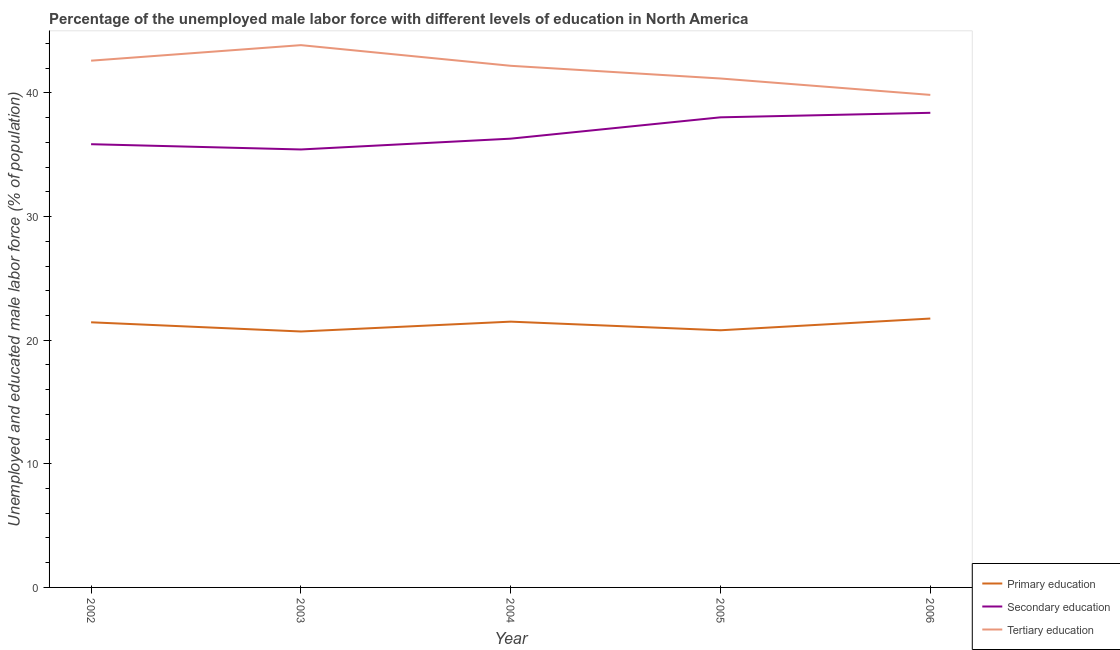How many different coloured lines are there?
Your answer should be very brief. 3. What is the percentage of male labor force who received tertiary education in 2005?
Your answer should be very brief. 41.17. Across all years, what is the maximum percentage of male labor force who received secondary education?
Provide a succinct answer. 38.39. Across all years, what is the minimum percentage of male labor force who received tertiary education?
Provide a short and direct response. 39.84. In which year was the percentage of male labor force who received primary education maximum?
Your answer should be compact. 2006. What is the total percentage of male labor force who received secondary education in the graph?
Offer a terse response. 184.01. What is the difference between the percentage of male labor force who received secondary education in 2005 and that in 2006?
Your answer should be compact. -0.36. What is the difference between the percentage of male labor force who received primary education in 2003 and the percentage of male labor force who received tertiary education in 2002?
Give a very brief answer. -21.91. What is the average percentage of male labor force who received tertiary education per year?
Offer a very short reply. 41.94. In the year 2003, what is the difference between the percentage of male labor force who received primary education and percentage of male labor force who received tertiary education?
Provide a short and direct response. -23.16. In how many years, is the percentage of male labor force who received secondary education greater than 2 %?
Provide a succinct answer. 5. What is the ratio of the percentage of male labor force who received secondary education in 2002 to that in 2004?
Provide a succinct answer. 0.99. Is the percentage of male labor force who received secondary education in 2002 less than that in 2005?
Offer a terse response. Yes. Is the difference between the percentage of male labor force who received primary education in 2002 and 2005 greater than the difference between the percentage of male labor force who received tertiary education in 2002 and 2005?
Provide a succinct answer. No. What is the difference between the highest and the second highest percentage of male labor force who received primary education?
Offer a very short reply. 0.25. What is the difference between the highest and the lowest percentage of male labor force who received tertiary education?
Provide a succinct answer. 4.02. In how many years, is the percentage of male labor force who received tertiary education greater than the average percentage of male labor force who received tertiary education taken over all years?
Your response must be concise. 3. Does the percentage of male labor force who received tertiary education monotonically increase over the years?
Your answer should be compact. No. Is the percentage of male labor force who received primary education strictly less than the percentage of male labor force who received tertiary education over the years?
Provide a short and direct response. Yes. Are the values on the major ticks of Y-axis written in scientific E-notation?
Provide a succinct answer. No. Does the graph contain any zero values?
Your answer should be very brief. No. How many legend labels are there?
Your response must be concise. 3. What is the title of the graph?
Offer a very short reply. Percentage of the unemployed male labor force with different levels of education in North America. What is the label or title of the Y-axis?
Keep it short and to the point. Unemployed and educated male labor force (% of population). What is the Unemployed and educated male labor force (% of population) of Primary education in 2002?
Provide a succinct answer. 21.45. What is the Unemployed and educated male labor force (% of population) in Secondary education in 2002?
Offer a terse response. 35.85. What is the Unemployed and educated male labor force (% of population) in Tertiary education in 2002?
Provide a short and direct response. 42.61. What is the Unemployed and educated male labor force (% of population) of Primary education in 2003?
Your answer should be compact. 20.7. What is the Unemployed and educated male labor force (% of population) in Secondary education in 2003?
Ensure brevity in your answer.  35.43. What is the Unemployed and educated male labor force (% of population) of Tertiary education in 2003?
Offer a very short reply. 43.87. What is the Unemployed and educated male labor force (% of population) of Primary education in 2004?
Make the answer very short. 21.5. What is the Unemployed and educated male labor force (% of population) of Secondary education in 2004?
Offer a very short reply. 36.3. What is the Unemployed and educated male labor force (% of population) of Tertiary education in 2004?
Keep it short and to the point. 42.2. What is the Unemployed and educated male labor force (% of population) of Primary education in 2005?
Provide a short and direct response. 20.8. What is the Unemployed and educated male labor force (% of population) in Secondary education in 2005?
Keep it short and to the point. 38.03. What is the Unemployed and educated male labor force (% of population) of Tertiary education in 2005?
Offer a very short reply. 41.17. What is the Unemployed and educated male labor force (% of population) in Primary education in 2006?
Your answer should be very brief. 21.75. What is the Unemployed and educated male labor force (% of population) in Secondary education in 2006?
Offer a very short reply. 38.39. What is the Unemployed and educated male labor force (% of population) of Tertiary education in 2006?
Ensure brevity in your answer.  39.84. Across all years, what is the maximum Unemployed and educated male labor force (% of population) of Primary education?
Offer a very short reply. 21.75. Across all years, what is the maximum Unemployed and educated male labor force (% of population) of Secondary education?
Your answer should be very brief. 38.39. Across all years, what is the maximum Unemployed and educated male labor force (% of population) in Tertiary education?
Make the answer very short. 43.87. Across all years, what is the minimum Unemployed and educated male labor force (% of population) in Primary education?
Keep it short and to the point. 20.7. Across all years, what is the minimum Unemployed and educated male labor force (% of population) of Secondary education?
Make the answer very short. 35.43. Across all years, what is the minimum Unemployed and educated male labor force (% of population) of Tertiary education?
Your response must be concise. 39.84. What is the total Unemployed and educated male labor force (% of population) in Primary education in the graph?
Give a very brief answer. 106.21. What is the total Unemployed and educated male labor force (% of population) in Secondary education in the graph?
Give a very brief answer. 184.01. What is the total Unemployed and educated male labor force (% of population) of Tertiary education in the graph?
Ensure brevity in your answer.  209.69. What is the difference between the Unemployed and educated male labor force (% of population) in Primary education in 2002 and that in 2003?
Your answer should be compact. 0.74. What is the difference between the Unemployed and educated male labor force (% of population) in Secondary education in 2002 and that in 2003?
Your response must be concise. 0.43. What is the difference between the Unemployed and educated male labor force (% of population) of Tertiary education in 2002 and that in 2003?
Your response must be concise. -1.26. What is the difference between the Unemployed and educated male labor force (% of population) of Primary education in 2002 and that in 2004?
Your answer should be compact. -0.05. What is the difference between the Unemployed and educated male labor force (% of population) of Secondary education in 2002 and that in 2004?
Offer a very short reply. -0.45. What is the difference between the Unemployed and educated male labor force (% of population) in Tertiary education in 2002 and that in 2004?
Provide a short and direct response. 0.41. What is the difference between the Unemployed and educated male labor force (% of population) of Primary education in 2002 and that in 2005?
Your answer should be very brief. 0.65. What is the difference between the Unemployed and educated male labor force (% of population) of Secondary education in 2002 and that in 2005?
Make the answer very short. -2.17. What is the difference between the Unemployed and educated male labor force (% of population) of Tertiary education in 2002 and that in 2005?
Provide a short and direct response. 1.44. What is the difference between the Unemployed and educated male labor force (% of population) in Primary education in 2002 and that in 2006?
Your answer should be compact. -0.3. What is the difference between the Unemployed and educated male labor force (% of population) in Secondary education in 2002 and that in 2006?
Make the answer very short. -2.54. What is the difference between the Unemployed and educated male labor force (% of population) in Tertiary education in 2002 and that in 2006?
Give a very brief answer. 2.77. What is the difference between the Unemployed and educated male labor force (% of population) of Primary education in 2003 and that in 2004?
Offer a very short reply. -0.8. What is the difference between the Unemployed and educated male labor force (% of population) of Secondary education in 2003 and that in 2004?
Keep it short and to the point. -0.88. What is the difference between the Unemployed and educated male labor force (% of population) of Tertiary education in 2003 and that in 2004?
Provide a short and direct response. 1.67. What is the difference between the Unemployed and educated male labor force (% of population) in Primary education in 2003 and that in 2005?
Give a very brief answer. -0.1. What is the difference between the Unemployed and educated male labor force (% of population) of Secondary education in 2003 and that in 2005?
Provide a succinct answer. -2.6. What is the difference between the Unemployed and educated male labor force (% of population) of Tertiary education in 2003 and that in 2005?
Provide a succinct answer. 2.7. What is the difference between the Unemployed and educated male labor force (% of population) in Primary education in 2003 and that in 2006?
Ensure brevity in your answer.  -1.05. What is the difference between the Unemployed and educated male labor force (% of population) in Secondary education in 2003 and that in 2006?
Ensure brevity in your answer.  -2.97. What is the difference between the Unemployed and educated male labor force (% of population) of Tertiary education in 2003 and that in 2006?
Your answer should be compact. 4.02. What is the difference between the Unemployed and educated male labor force (% of population) of Primary education in 2004 and that in 2005?
Ensure brevity in your answer.  0.7. What is the difference between the Unemployed and educated male labor force (% of population) of Secondary education in 2004 and that in 2005?
Provide a short and direct response. -1.73. What is the difference between the Unemployed and educated male labor force (% of population) of Tertiary education in 2004 and that in 2005?
Make the answer very short. 1.03. What is the difference between the Unemployed and educated male labor force (% of population) of Primary education in 2004 and that in 2006?
Your answer should be very brief. -0.25. What is the difference between the Unemployed and educated male labor force (% of population) in Secondary education in 2004 and that in 2006?
Ensure brevity in your answer.  -2.09. What is the difference between the Unemployed and educated male labor force (% of population) of Tertiary education in 2004 and that in 2006?
Your answer should be very brief. 2.35. What is the difference between the Unemployed and educated male labor force (% of population) in Primary education in 2005 and that in 2006?
Keep it short and to the point. -0.95. What is the difference between the Unemployed and educated male labor force (% of population) of Secondary education in 2005 and that in 2006?
Offer a very short reply. -0.36. What is the difference between the Unemployed and educated male labor force (% of population) of Tertiary education in 2005 and that in 2006?
Provide a short and direct response. 1.33. What is the difference between the Unemployed and educated male labor force (% of population) in Primary education in 2002 and the Unemployed and educated male labor force (% of population) in Secondary education in 2003?
Give a very brief answer. -13.98. What is the difference between the Unemployed and educated male labor force (% of population) in Primary education in 2002 and the Unemployed and educated male labor force (% of population) in Tertiary education in 2003?
Ensure brevity in your answer.  -22.42. What is the difference between the Unemployed and educated male labor force (% of population) in Secondary education in 2002 and the Unemployed and educated male labor force (% of population) in Tertiary education in 2003?
Your answer should be compact. -8.01. What is the difference between the Unemployed and educated male labor force (% of population) in Primary education in 2002 and the Unemployed and educated male labor force (% of population) in Secondary education in 2004?
Your answer should be compact. -14.86. What is the difference between the Unemployed and educated male labor force (% of population) of Primary education in 2002 and the Unemployed and educated male labor force (% of population) of Tertiary education in 2004?
Your answer should be compact. -20.75. What is the difference between the Unemployed and educated male labor force (% of population) of Secondary education in 2002 and the Unemployed and educated male labor force (% of population) of Tertiary education in 2004?
Offer a terse response. -6.34. What is the difference between the Unemployed and educated male labor force (% of population) of Primary education in 2002 and the Unemployed and educated male labor force (% of population) of Secondary education in 2005?
Ensure brevity in your answer.  -16.58. What is the difference between the Unemployed and educated male labor force (% of population) of Primary education in 2002 and the Unemployed and educated male labor force (% of population) of Tertiary education in 2005?
Provide a short and direct response. -19.72. What is the difference between the Unemployed and educated male labor force (% of population) in Secondary education in 2002 and the Unemployed and educated male labor force (% of population) in Tertiary education in 2005?
Provide a short and direct response. -5.31. What is the difference between the Unemployed and educated male labor force (% of population) of Primary education in 2002 and the Unemployed and educated male labor force (% of population) of Secondary education in 2006?
Your answer should be very brief. -16.95. What is the difference between the Unemployed and educated male labor force (% of population) in Primary education in 2002 and the Unemployed and educated male labor force (% of population) in Tertiary education in 2006?
Your response must be concise. -18.39. What is the difference between the Unemployed and educated male labor force (% of population) of Secondary education in 2002 and the Unemployed and educated male labor force (% of population) of Tertiary education in 2006?
Provide a succinct answer. -3.99. What is the difference between the Unemployed and educated male labor force (% of population) of Primary education in 2003 and the Unemployed and educated male labor force (% of population) of Secondary education in 2004?
Your answer should be compact. -15.6. What is the difference between the Unemployed and educated male labor force (% of population) in Primary education in 2003 and the Unemployed and educated male labor force (% of population) in Tertiary education in 2004?
Ensure brevity in your answer.  -21.49. What is the difference between the Unemployed and educated male labor force (% of population) of Secondary education in 2003 and the Unemployed and educated male labor force (% of population) of Tertiary education in 2004?
Your answer should be very brief. -6.77. What is the difference between the Unemployed and educated male labor force (% of population) of Primary education in 2003 and the Unemployed and educated male labor force (% of population) of Secondary education in 2005?
Offer a terse response. -17.32. What is the difference between the Unemployed and educated male labor force (% of population) in Primary education in 2003 and the Unemployed and educated male labor force (% of population) in Tertiary education in 2005?
Keep it short and to the point. -20.46. What is the difference between the Unemployed and educated male labor force (% of population) of Secondary education in 2003 and the Unemployed and educated male labor force (% of population) of Tertiary education in 2005?
Offer a very short reply. -5.74. What is the difference between the Unemployed and educated male labor force (% of population) of Primary education in 2003 and the Unemployed and educated male labor force (% of population) of Secondary education in 2006?
Keep it short and to the point. -17.69. What is the difference between the Unemployed and educated male labor force (% of population) in Primary education in 2003 and the Unemployed and educated male labor force (% of population) in Tertiary education in 2006?
Give a very brief answer. -19.14. What is the difference between the Unemployed and educated male labor force (% of population) of Secondary education in 2003 and the Unemployed and educated male labor force (% of population) of Tertiary education in 2006?
Offer a terse response. -4.42. What is the difference between the Unemployed and educated male labor force (% of population) of Primary education in 2004 and the Unemployed and educated male labor force (% of population) of Secondary education in 2005?
Make the answer very short. -16.53. What is the difference between the Unemployed and educated male labor force (% of population) of Primary education in 2004 and the Unemployed and educated male labor force (% of population) of Tertiary education in 2005?
Offer a terse response. -19.67. What is the difference between the Unemployed and educated male labor force (% of population) of Secondary education in 2004 and the Unemployed and educated male labor force (% of population) of Tertiary education in 2005?
Provide a short and direct response. -4.87. What is the difference between the Unemployed and educated male labor force (% of population) in Primary education in 2004 and the Unemployed and educated male labor force (% of population) in Secondary education in 2006?
Make the answer very short. -16.89. What is the difference between the Unemployed and educated male labor force (% of population) in Primary education in 2004 and the Unemployed and educated male labor force (% of population) in Tertiary education in 2006?
Your answer should be compact. -18.34. What is the difference between the Unemployed and educated male labor force (% of population) of Secondary education in 2004 and the Unemployed and educated male labor force (% of population) of Tertiary education in 2006?
Your response must be concise. -3.54. What is the difference between the Unemployed and educated male labor force (% of population) of Primary education in 2005 and the Unemployed and educated male labor force (% of population) of Secondary education in 2006?
Offer a terse response. -17.59. What is the difference between the Unemployed and educated male labor force (% of population) of Primary education in 2005 and the Unemployed and educated male labor force (% of population) of Tertiary education in 2006?
Give a very brief answer. -19.04. What is the difference between the Unemployed and educated male labor force (% of population) in Secondary education in 2005 and the Unemployed and educated male labor force (% of population) in Tertiary education in 2006?
Keep it short and to the point. -1.81. What is the average Unemployed and educated male labor force (% of population) in Primary education per year?
Your answer should be very brief. 21.24. What is the average Unemployed and educated male labor force (% of population) in Secondary education per year?
Your answer should be very brief. 36.8. What is the average Unemployed and educated male labor force (% of population) of Tertiary education per year?
Offer a terse response. 41.94. In the year 2002, what is the difference between the Unemployed and educated male labor force (% of population) in Primary education and Unemployed and educated male labor force (% of population) in Secondary education?
Your answer should be compact. -14.41. In the year 2002, what is the difference between the Unemployed and educated male labor force (% of population) of Primary education and Unemployed and educated male labor force (% of population) of Tertiary education?
Offer a very short reply. -21.16. In the year 2002, what is the difference between the Unemployed and educated male labor force (% of population) of Secondary education and Unemployed and educated male labor force (% of population) of Tertiary education?
Keep it short and to the point. -6.76. In the year 2003, what is the difference between the Unemployed and educated male labor force (% of population) of Primary education and Unemployed and educated male labor force (% of population) of Secondary education?
Your answer should be very brief. -14.72. In the year 2003, what is the difference between the Unemployed and educated male labor force (% of population) of Primary education and Unemployed and educated male labor force (% of population) of Tertiary education?
Offer a terse response. -23.16. In the year 2003, what is the difference between the Unemployed and educated male labor force (% of population) of Secondary education and Unemployed and educated male labor force (% of population) of Tertiary education?
Provide a succinct answer. -8.44. In the year 2004, what is the difference between the Unemployed and educated male labor force (% of population) of Primary education and Unemployed and educated male labor force (% of population) of Secondary education?
Ensure brevity in your answer.  -14.8. In the year 2004, what is the difference between the Unemployed and educated male labor force (% of population) of Primary education and Unemployed and educated male labor force (% of population) of Tertiary education?
Your answer should be compact. -20.7. In the year 2004, what is the difference between the Unemployed and educated male labor force (% of population) of Secondary education and Unemployed and educated male labor force (% of population) of Tertiary education?
Ensure brevity in your answer.  -5.89. In the year 2005, what is the difference between the Unemployed and educated male labor force (% of population) of Primary education and Unemployed and educated male labor force (% of population) of Secondary education?
Your answer should be very brief. -17.23. In the year 2005, what is the difference between the Unemployed and educated male labor force (% of population) in Primary education and Unemployed and educated male labor force (% of population) in Tertiary education?
Make the answer very short. -20.37. In the year 2005, what is the difference between the Unemployed and educated male labor force (% of population) in Secondary education and Unemployed and educated male labor force (% of population) in Tertiary education?
Ensure brevity in your answer.  -3.14. In the year 2006, what is the difference between the Unemployed and educated male labor force (% of population) in Primary education and Unemployed and educated male labor force (% of population) in Secondary education?
Offer a terse response. -16.64. In the year 2006, what is the difference between the Unemployed and educated male labor force (% of population) of Primary education and Unemployed and educated male labor force (% of population) of Tertiary education?
Offer a very short reply. -18.09. In the year 2006, what is the difference between the Unemployed and educated male labor force (% of population) of Secondary education and Unemployed and educated male labor force (% of population) of Tertiary education?
Your answer should be very brief. -1.45. What is the ratio of the Unemployed and educated male labor force (% of population) of Primary education in 2002 to that in 2003?
Your answer should be very brief. 1.04. What is the ratio of the Unemployed and educated male labor force (% of population) in Secondary education in 2002 to that in 2003?
Provide a succinct answer. 1.01. What is the ratio of the Unemployed and educated male labor force (% of population) in Tertiary education in 2002 to that in 2003?
Your answer should be very brief. 0.97. What is the ratio of the Unemployed and educated male labor force (% of population) in Secondary education in 2002 to that in 2004?
Make the answer very short. 0.99. What is the ratio of the Unemployed and educated male labor force (% of population) in Tertiary education in 2002 to that in 2004?
Keep it short and to the point. 1.01. What is the ratio of the Unemployed and educated male labor force (% of population) of Primary education in 2002 to that in 2005?
Keep it short and to the point. 1.03. What is the ratio of the Unemployed and educated male labor force (% of population) of Secondary education in 2002 to that in 2005?
Keep it short and to the point. 0.94. What is the ratio of the Unemployed and educated male labor force (% of population) of Tertiary education in 2002 to that in 2005?
Provide a short and direct response. 1.03. What is the ratio of the Unemployed and educated male labor force (% of population) in Primary education in 2002 to that in 2006?
Give a very brief answer. 0.99. What is the ratio of the Unemployed and educated male labor force (% of population) of Secondary education in 2002 to that in 2006?
Ensure brevity in your answer.  0.93. What is the ratio of the Unemployed and educated male labor force (% of population) of Tertiary education in 2002 to that in 2006?
Give a very brief answer. 1.07. What is the ratio of the Unemployed and educated male labor force (% of population) in Primary education in 2003 to that in 2004?
Make the answer very short. 0.96. What is the ratio of the Unemployed and educated male labor force (% of population) of Secondary education in 2003 to that in 2004?
Keep it short and to the point. 0.98. What is the ratio of the Unemployed and educated male labor force (% of population) of Tertiary education in 2003 to that in 2004?
Provide a succinct answer. 1.04. What is the ratio of the Unemployed and educated male labor force (% of population) of Primary education in 2003 to that in 2005?
Your answer should be compact. 1. What is the ratio of the Unemployed and educated male labor force (% of population) of Secondary education in 2003 to that in 2005?
Make the answer very short. 0.93. What is the ratio of the Unemployed and educated male labor force (% of population) of Tertiary education in 2003 to that in 2005?
Make the answer very short. 1.07. What is the ratio of the Unemployed and educated male labor force (% of population) in Primary education in 2003 to that in 2006?
Keep it short and to the point. 0.95. What is the ratio of the Unemployed and educated male labor force (% of population) of Secondary education in 2003 to that in 2006?
Make the answer very short. 0.92. What is the ratio of the Unemployed and educated male labor force (% of population) in Tertiary education in 2003 to that in 2006?
Offer a very short reply. 1.1. What is the ratio of the Unemployed and educated male labor force (% of population) of Primary education in 2004 to that in 2005?
Your response must be concise. 1.03. What is the ratio of the Unemployed and educated male labor force (% of population) of Secondary education in 2004 to that in 2005?
Make the answer very short. 0.95. What is the ratio of the Unemployed and educated male labor force (% of population) of Primary education in 2004 to that in 2006?
Your response must be concise. 0.99. What is the ratio of the Unemployed and educated male labor force (% of population) of Secondary education in 2004 to that in 2006?
Give a very brief answer. 0.95. What is the ratio of the Unemployed and educated male labor force (% of population) of Tertiary education in 2004 to that in 2006?
Ensure brevity in your answer.  1.06. What is the ratio of the Unemployed and educated male labor force (% of population) in Primary education in 2005 to that in 2006?
Keep it short and to the point. 0.96. What is the ratio of the Unemployed and educated male labor force (% of population) in Tertiary education in 2005 to that in 2006?
Provide a short and direct response. 1.03. What is the difference between the highest and the second highest Unemployed and educated male labor force (% of population) of Primary education?
Provide a succinct answer. 0.25. What is the difference between the highest and the second highest Unemployed and educated male labor force (% of population) of Secondary education?
Keep it short and to the point. 0.36. What is the difference between the highest and the second highest Unemployed and educated male labor force (% of population) in Tertiary education?
Offer a terse response. 1.26. What is the difference between the highest and the lowest Unemployed and educated male labor force (% of population) of Primary education?
Your response must be concise. 1.05. What is the difference between the highest and the lowest Unemployed and educated male labor force (% of population) of Secondary education?
Your response must be concise. 2.97. What is the difference between the highest and the lowest Unemployed and educated male labor force (% of population) of Tertiary education?
Give a very brief answer. 4.02. 